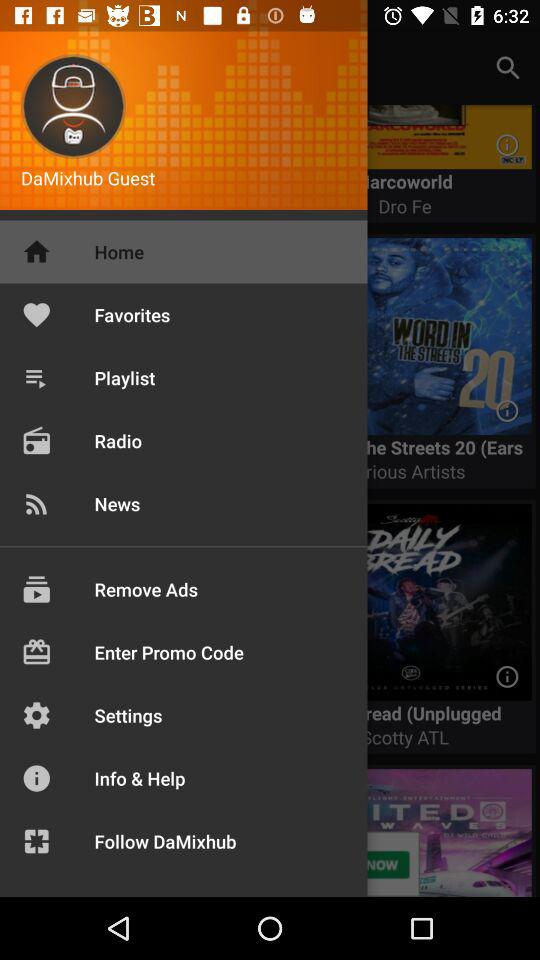What is the name of the application? The application name is "DaMixhub". 